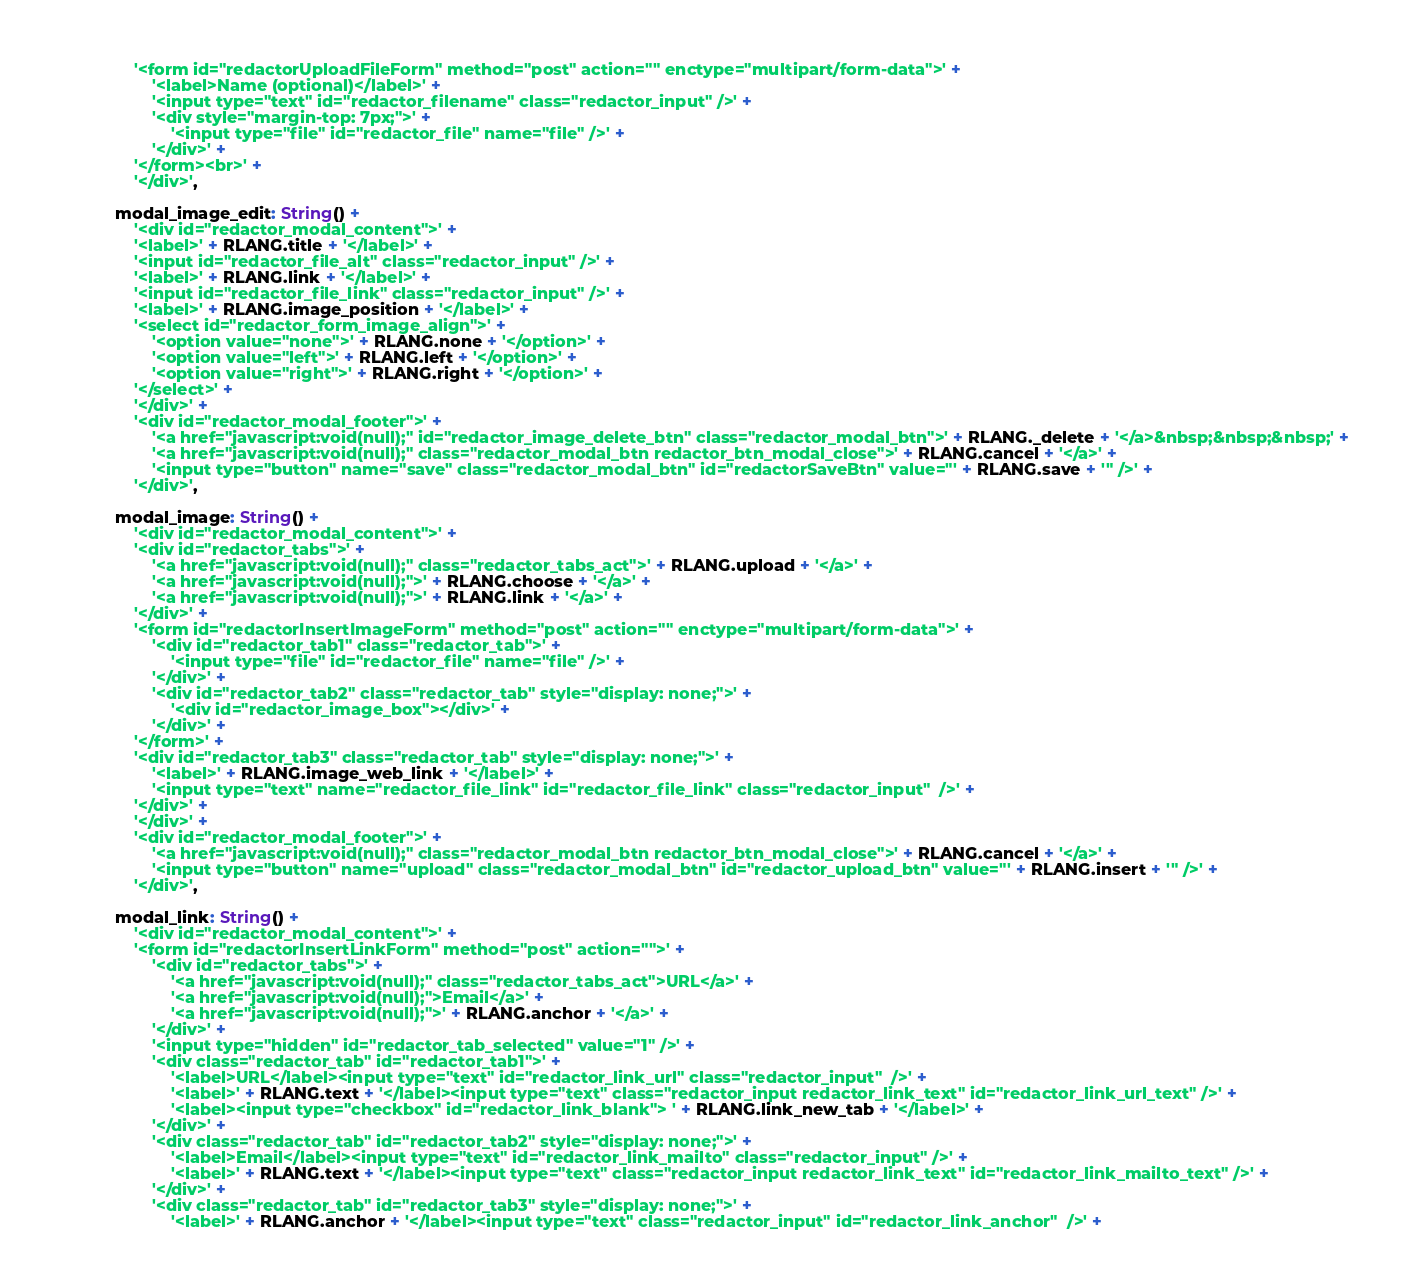<code> <loc_0><loc_0><loc_500><loc_500><_JavaScript_>				'<form id="redactorUploadFileForm" method="post" action="" enctype="multipart/form-data">' +
					'<label>Name (optional)</label>' +
					'<input type="text" id="redactor_filename" class="redactor_input" />' +
					'<div style="margin-top: 7px;">' +
						'<input type="file" id="redactor_file" name="file" />' +
					'</div>' +
				'</form><br>' +
				'</div>',

			modal_image_edit: String() +
				'<div id="redactor_modal_content">' +
				'<label>' + RLANG.title + '</label>' +
				'<input id="redactor_file_alt" class="redactor_input" />' +
				'<label>' + RLANG.link + '</label>' +
				'<input id="redactor_file_link" class="redactor_input" />' +
				'<label>' + RLANG.image_position + '</label>' +
				'<select id="redactor_form_image_align">' +
					'<option value="none">' + RLANG.none + '</option>' +
					'<option value="left">' + RLANG.left + '</option>' +
					'<option value="right">' + RLANG.right + '</option>' +
				'</select>' +
				'</div>' +
				'<div id="redactor_modal_footer">' +
					'<a href="javascript:void(null);" id="redactor_image_delete_btn" class="redactor_modal_btn">' + RLANG._delete + '</a>&nbsp;&nbsp;&nbsp;' +
					'<a href="javascript:void(null);" class="redactor_modal_btn redactor_btn_modal_close">' + RLANG.cancel + '</a>' +
					'<input type="button" name="save" class="redactor_modal_btn" id="redactorSaveBtn" value="' + RLANG.save + '" />' +
				'</div>',

			modal_image: String() +
				'<div id="redactor_modal_content">' +
				'<div id="redactor_tabs">' +
					'<a href="javascript:void(null);" class="redactor_tabs_act">' + RLANG.upload + '</a>' +
					'<a href="javascript:void(null);">' + RLANG.choose + '</a>' +
					'<a href="javascript:void(null);">' + RLANG.link + '</a>' +
				'</div>' +
				'<form id="redactorInsertImageForm" method="post" action="" enctype="multipart/form-data">' +
					'<div id="redactor_tab1" class="redactor_tab">' +
						'<input type="file" id="redactor_file" name="file" />' +
					'</div>' +
					'<div id="redactor_tab2" class="redactor_tab" style="display: none;">' +
						'<div id="redactor_image_box"></div>' +
					'</div>' +
				'</form>' +
				'<div id="redactor_tab3" class="redactor_tab" style="display: none;">' +
					'<label>' + RLANG.image_web_link + '</label>' +
					'<input type="text" name="redactor_file_link" id="redactor_file_link" class="redactor_input"  />' +
				'</div>' +
				'</div>' +
				'<div id="redactor_modal_footer">' +
					'<a href="javascript:void(null);" class="redactor_modal_btn redactor_btn_modal_close">' + RLANG.cancel + '</a>' +
					'<input type="button" name="upload" class="redactor_modal_btn" id="redactor_upload_btn" value="' + RLANG.insert + '" />' +
				'</div>',

			modal_link: String() +
				'<div id="redactor_modal_content">' +
				'<form id="redactorInsertLinkForm" method="post" action="">' +
					'<div id="redactor_tabs">' +
						'<a href="javascript:void(null);" class="redactor_tabs_act">URL</a>' +
						'<a href="javascript:void(null);">Email</a>' +
						'<a href="javascript:void(null);">' + RLANG.anchor + '</a>' +
					'</div>' +
					'<input type="hidden" id="redactor_tab_selected" value="1" />' +
					'<div class="redactor_tab" id="redactor_tab1">' +
						'<label>URL</label><input type="text" id="redactor_link_url" class="redactor_input"  />' +
						'<label>' + RLANG.text + '</label><input type="text" class="redactor_input redactor_link_text" id="redactor_link_url_text" />' +
						'<label><input type="checkbox" id="redactor_link_blank"> ' + RLANG.link_new_tab + '</label>' +
					'</div>' +
					'<div class="redactor_tab" id="redactor_tab2" style="display: none;">' +
						'<label>Email</label><input type="text" id="redactor_link_mailto" class="redactor_input" />' +
						'<label>' + RLANG.text + '</label><input type="text" class="redactor_input redactor_link_text" id="redactor_link_mailto_text" />' +
					'</div>' +
					'<div class="redactor_tab" id="redactor_tab3" style="display: none;">' +
						'<label>' + RLANG.anchor + '</label><input type="text" class="redactor_input" id="redactor_link_anchor"  />' +</code> 